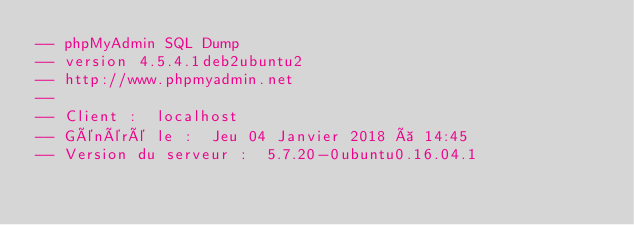Convert code to text. <code><loc_0><loc_0><loc_500><loc_500><_SQL_>-- phpMyAdmin SQL Dump
-- version 4.5.4.1deb2ubuntu2
-- http://www.phpmyadmin.net
--
-- Client :  localhost
-- Généré le :  Jeu 04 Janvier 2018 à 14:45
-- Version du serveur :  5.7.20-0ubuntu0.16.04.1</code> 